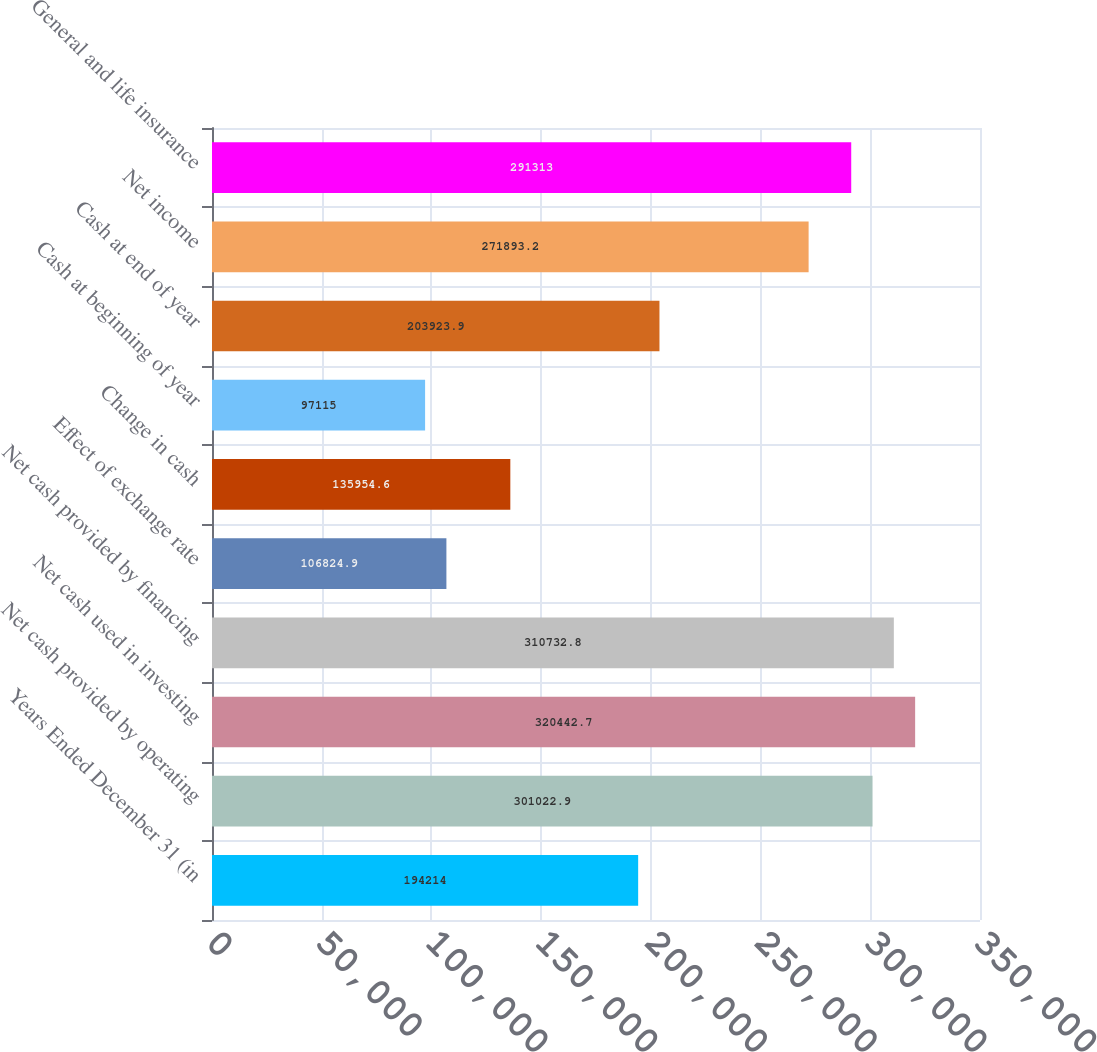Convert chart. <chart><loc_0><loc_0><loc_500><loc_500><bar_chart><fcel>Years Ended December 31 (in<fcel>Net cash provided by operating<fcel>Net cash used in investing<fcel>Net cash provided by financing<fcel>Effect of exchange rate<fcel>Change in cash<fcel>Cash at beginning of year<fcel>Cash at end of year<fcel>Net income<fcel>General and life insurance<nl><fcel>194214<fcel>301023<fcel>320443<fcel>310733<fcel>106825<fcel>135955<fcel>97115<fcel>203924<fcel>271893<fcel>291313<nl></chart> 